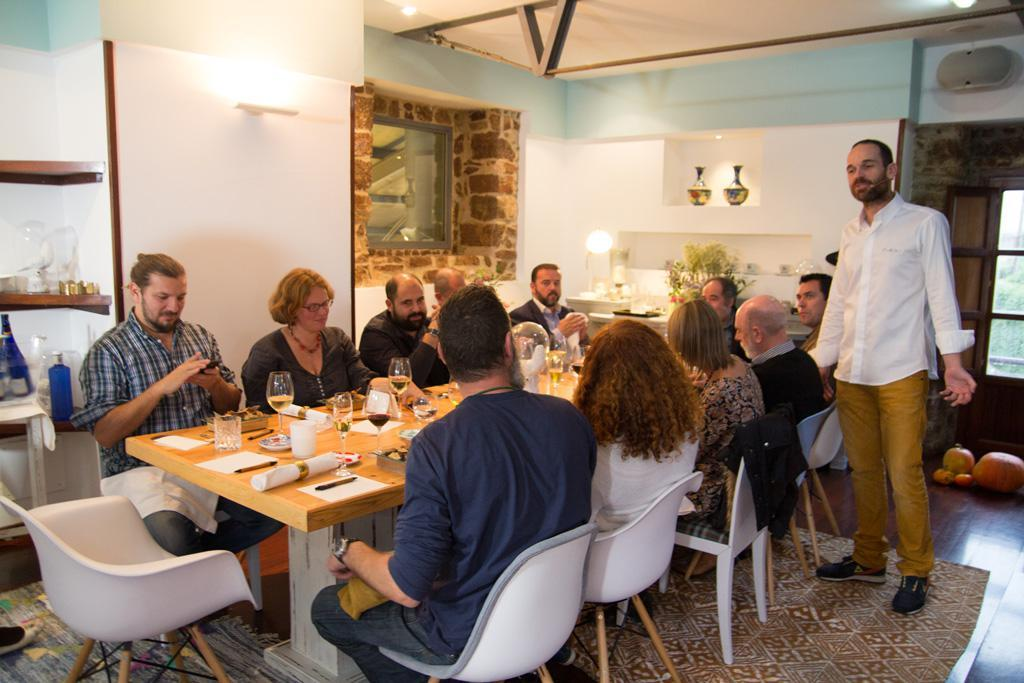What is the color of the wall in the image? The wall in the image is white. What can be seen illuminating the area in the image? There are lights in the image. What are the people in the image doing? The people in the image are sitting on chairs. What is on the table in the image? There is a table in the image with a paper, a pen, a book, glasses, and bottles on it. What type of dress is the doll wearing in the image? There are no dolls present in the image, so it is not possible to answer that question. What type of building can be seen in the background of the image? The image does not show any building in the background; it only features a white wall, lights, people sitting on chairs, and a table with various items on it. 